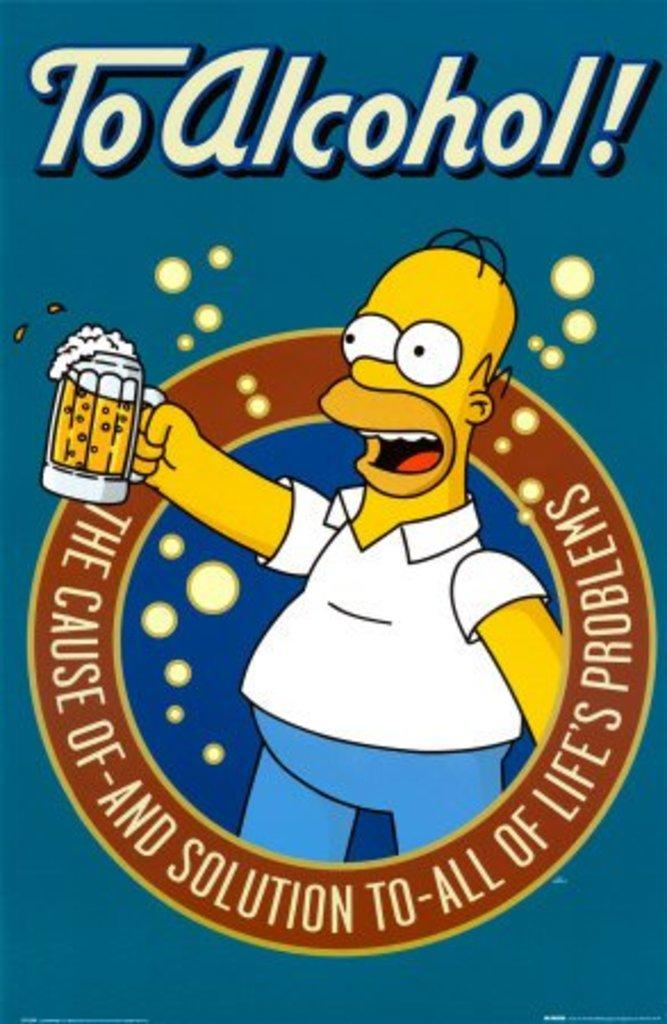What type of character is depicted in the image? There is a cartoon character in the image. What is the cartoon character holding? The cartoon character is holding a glass. What color is the shirt worn by the cartoon character? The cartoon character is wearing a white shirt. What color are the pants worn by the cartoon character? The cartoon character is wearing blue pants. What can be seen in addition to the cartoon character in the image? There is text or writing visible in the image. What type of activity is the cartoon character engaged in with the roll in the image? There is no roll present in the image; the cartoon character is holding a glass. 